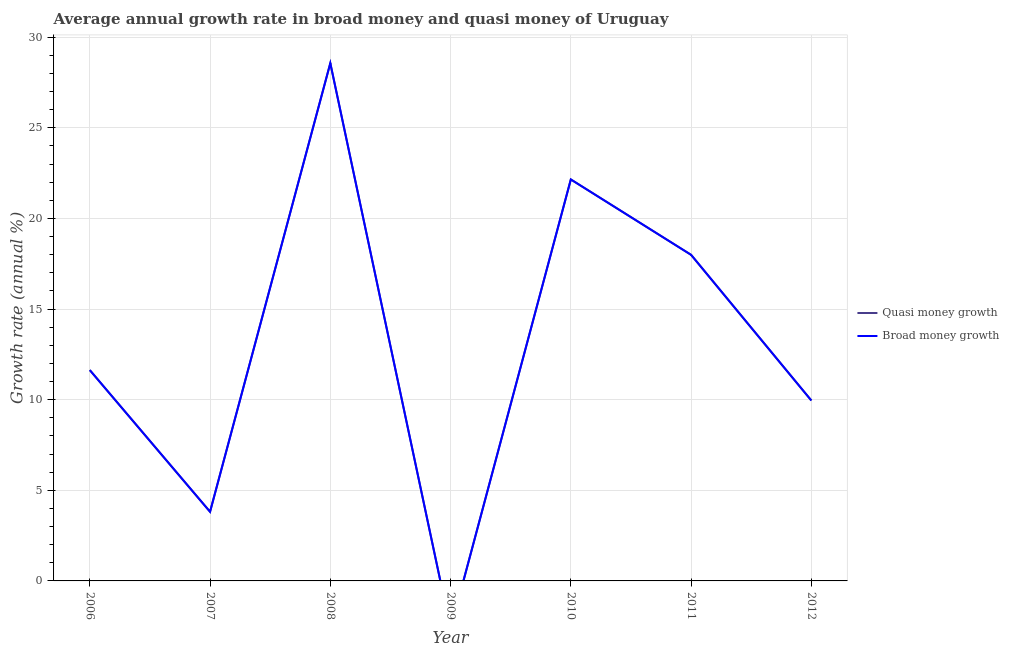Is the number of lines equal to the number of legend labels?
Ensure brevity in your answer.  No. What is the annual growth rate in quasi money in 2007?
Your answer should be compact. 3.82. Across all years, what is the maximum annual growth rate in broad money?
Your answer should be compact. 28.57. What is the total annual growth rate in broad money in the graph?
Provide a short and direct response. 94.11. What is the difference between the annual growth rate in quasi money in 2007 and that in 2008?
Make the answer very short. -24.75. What is the difference between the annual growth rate in broad money in 2007 and the annual growth rate in quasi money in 2008?
Offer a very short reply. -24.75. What is the average annual growth rate in quasi money per year?
Offer a terse response. 13.44. In the year 2012, what is the difference between the annual growth rate in broad money and annual growth rate in quasi money?
Your answer should be very brief. 0. In how many years, is the annual growth rate in quasi money greater than 3 %?
Keep it short and to the point. 6. What is the ratio of the annual growth rate in broad money in 2006 to that in 2010?
Ensure brevity in your answer.  0.53. What is the difference between the highest and the second highest annual growth rate in quasi money?
Your answer should be compact. 6.42. What is the difference between the highest and the lowest annual growth rate in quasi money?
Your answer should be compact. 28.57. In how many years, is the annual growth rate in quasi money greater than the average annual growth rate in quasi money taken over all years?
Provide a succinct answer. 3. Is the annual growth rate in quasi money strictly greater than the annual growth rate in broad money over the years?
Provide a short and direct response. No. How many lines are there?
Offer a very short reply. 2. What is the difference between two consecutive major ticks on the Y-axis?
Offer a very short reply. 5. Does the graph contain any zero values?
Ensure brevity in your answer.  Yes. How many legend labels are there?
Provide a succinct answer. 2. How are the legend labels stacked?
Your response must be concise. Vertical. What is the title of the graph?
Provide a succinct answer. Average annual growth rate in broad money and quasi money of Uruguay. What is the label or title of the Y-axis?
Your answer should be compact. Growth rate (annual %). What is the Growth rate (annual %) of Quasi money growth in 2006?
Ensure brevity in your answer.  11.63. What is the Growth rate (annual %) of Broad money growth in 2006?
Your response must be concise. 11.63. What is the Growth rate (annual %) in Quasi money growth in 2007?
Provide a succinct answer. 3.82. What is the Growth rate (annual %) of Broad money growth in 2007?
Offer a terse response. 3.82. What is the Growth rate (annual %) in Quasi money growth in 2008?
Keep it short and to the point. 28.57. What is the Growth rate (annual %) in Broad money growth in 2008?
Give a very brief answer. 28.57. What is the Growth rate (annual %) in Quasi money growth in 2009?
Ensure brevity in your answer.  0. What is the Growth rate (annual %) in Broad money growth in 2009?
Provide a succinct answer. 0. What is the Growth rate (annual %) in Quasi money growth in 2010?
Provide a short and direct response. 22.15. What is the Growth rate (annual %) of Broad money growth in 2010?
Provide a short and direct response. 22.15. What is the Growth rate (annual %) of Quasi money growth in 2011?
Offer a terse response. 17.99. What is the Growth rate (annual %) in Broad money growth in 2011?
Offer a terse response. 17.99. What is the Growth rate (annual %) of Quasi money growth in 2012?
Keep it short and to the point. 9.95. What is the Growth rate (annual %) of Broad money growth in 2012?
Give a very brief answer. 9.95. Across all years, what is the maximum Growth rate (annual %) of Quasi money growth?
Provide a succinct answer. 28.57. Across all years, what is the maximum Growth rate (annual %) in Broad money growth?
Give a very brief answer. 28.57. Across all years, what is the minimum Growth rate (annual %) in Quasi money growth?
Your answer should be very brief. 0. Across all years, what is the minimum Growth rate (annual %) in Broad money growth?
Keep it short and to the point. 0. What is the total Growth rate (annual %) in Quasi money growth in the graph?
Your answer should be very brief. 94.11. What is the total Growth rate (annual %) in Broad money growth in the graph?
Provide a short and direct response. 94.11. What is the difference between the Growth rate (annual %) in Quasi money growth in 2006 and that in 2007?
Offer a very short reply. 7.82. What is the difference between the Growth rate (annual %) in Broad money growth in 2006 and that in 2007?
Offer a very short reply. 7.82. What is the difference between the Growth rate (annual %) of Quasi money growth in 2006 and that in 2008?
Your response must be concise. -16.93. What is the difference between the Growth rate (annual %) of Broad money growth in 2006 and that in 2008?
Keep it short and to the point. -16.93. What is the difference between the Growth rate (annual %) of Quasi money growth in 2006 and that in 2010?
Your answer should be very brief. -10.52. What is the difference between the Growth rate (annual %) of Broad money growth in 2006 and that in 2010?
Provide a short and direct response. -10.52. What is the difference between the Growth rate (annual %) of Quasi money growth in 2006 and that in 2011?
Keep it short and to the point. -6.36. What is the difference between the Growth rate (annual %) of Broad money growth in 2006 and that in 2011?
Your answer should be very brief. -6.36. What is the difference between the Growth rate (annual %) of Quasi money growth in 2006 and that in 2012?
Make the answer very short. 1.68. What is the difference between the Growth rate (annual %) in Broad money growth in 2006 and that in 2012?
Ensure brevity in your answer.  1.68. What is the difference between the Growth rate (annual %) of Quasi money growth in 2007 and that in 2008?
Offer a terse response. -24.75. What is the difference between the Growth rate (annual %) in Broad money growth in 2007 and that in 2008?
Offer a very short reply. -24.75. What is the difference between the Growth rate (annual %) of Quasi money growth in 2007 and that in 2010?
Your response must be concise. -18.33. What is the difference between the Growth rate (annual %) in Broad money growth in 2007 and that in 2010?
Your answer should be very brief. -18.33. What is the difference between the Growth rate (annual %) in Quasi money growth in 2007 and that in 2011?
Offer a very short reply. -14.18. What is the difference between the Growth rate (annual %) in Broad money growth in 2007 and that in 2011?
Your response must be concise. -14.18. What is the difference between the Growth rate (annual %) in Quasi money growth in 2007 and that in 2012?
Your answer should be very brief. -6.14. What is the difference between the Growth rate (annual %) in Broad money growth in 2007 and that in 2012?
Keep it short and to the point. -6.14. What is the difference between the Growth rate (annual %) of Quasi money growth in 2008 and that in 2010?
Provide a succinct answer. 6.42. What is the difference between the Growth rate (annual %) of Broad money growth in 2008 and that in 2010?
Keep it short and to the point. 6.42. What is the difference between the Growth rate (annual %) of Quasi money growth in 2008 and that in 2011?
Offer a terse response. 10.57. What is the difference between the Growth rate (annual %) of Broad money growth in 2008 and that in 2011?
Your response must be concise. 10.57. What is the difference between the Growth rate (annual %) of Quasi money growth in 2008 and that in 2012?
Keep it short and to the point. 18.61. What is the difference between the Growth rate (annual %) of Broad money growth in 2008 and that in 2012?
Offer a very short reply. 18.61. What is the difference between the Growth rate (annual %) in Quasi money growth in 2010 and that in 2011?
Your answer should be very brief. 4.16. What is the difference between the Growth rate (annual %) of Broad money growth in 2010 and that in 2011?
Your response must be concise. 4.16. What is the difference between the Growth rate (annual %) of Quasi money growth in 2010 and that in 2012?
Your answer should be compact. 12.2. What is the difference between the Growth rate (annual %) in Broad money growth in 2010 and that in 2012?
Keep it short and to the point. 12.2. What is the difference between the Growth rate (annual %) of Quasi money growth in 2011 and that in 2012?
Your answer should be compact. 8.04. What is the difference between the Growth rate (annual %) of Broad money growth in 2011 and that in 2012?
Provide a short and direct response. 8.04. What is the difference between the Growth rate (annual %) in Quasi money growth in 2006 and the Growth rate (annual %) in Broad money growth in 2007?
Provide a short and direct response. 7.82. What is the difference between the Growth rate (annual %) in Quasi money growth in 2006 and the Growth rate (annual %) in Broad money growth in 2008?
Your response must be concise. -16.93. What is the difference between the Growth rate (annual %) of Quasi money growth in 2006 and the Growth rate (annual %) of Broad money growth in 2010?
Keep it short and to the point. -10.52. What is the difference between the Growth rate (annual %) of Quasi money growth in 2006 and the Growth rate (annual %) of Broad money growth in 2011?
Make the answer very short. -6.36. What is the difference between the Growth rate (annual %) in Quasi money growth in 2006 and the Growth rate (annual %) in Broad money growth in 2012?
Keep it short and to the point. 1.68. What is the difference between the Growth rate (annual %) of Quasi money growth in 2007 and the Growth rate (annual %) of Broad money growth in 2008?
Provide a succinct answer. -24.75. What is the difference between the Growth rate (annual %) in Quasi money growth in 2007 and the Growth rate (annual %) in Broad money growth in 2010?
Provide a short and direct response. -18.33. What is the difference between the Growth rate (annual %) of Quasi money growth in 2007 and the Growth rate (annual %) of Broad money growth in 2011?
Your response must be concise. -14.18. What is the difference between the Growth rate (annual %) in Quasi money growth in 2007 and the Growth rate (annual %) in Broad money growth in 2012?
Your answer should be very brief. -6.14. What is the difference between the Growth rate (annual %) in Quasi money growth in 2008 and the Growth rate (annual %) in Broad money growth in 2010?
Make the answer very short. 6.42. What is the difference between the Growth rate (annual %) in Quasi money growth in 2008 and the Growth rate (annual %) in Broad money growth in 2011?
Make the answer very short. 10.57. What is the difference between the Growth rate (annual %) of Quasi money growth in 2008 and the Growth rate (annual %) of Broad money growth in 2012?
Keep it short and to the point. 18.61. What is the difference between the Growth rate (annual %) of Quasi money growth in 2010 and the Growth rate (annual %) of Broad money growth in 2011?
Your answer should be very brief. 4.16. What is the difference between the Growth rate (annual %) of Quasi money growth in 2010 and the Growth rate (annual %) of Broad money growth in 2012?
Make the answer very short. 12.2. What is the difference between the Growth rate (annual %) in Quasi money growth in 2011 and the Growth rate (annual %) in Broad money growth in 2012?
Your answer should be compact. 8.04. What is the average Growth rate (annual %) of Quasi money growth per year?
Provide a short and direct response. 13.44. What is the average Growth rate (annual %) in Broad money growth per year?
Offer a terse response. 13.44. What is the ratio of the Growth rate (annual %) of Quasi money growth in 2006 to that in 2007?
Make the answer very short. 3.05. What is the ratio of the Growth rate (annual %) of Broad money growth in 2006 to that in 2007?
Ensure brevity in your answer.  3.05. What is the ratio of the Growth rate (annual %) in Quasi money growth in 2006 to that in 2008?
Offer a very short reply. 0.41. What is the ratio of the Growth rate (annual %) in Broad money growth in 2006 to that in 2008?
Provide a short and direct response. 0.41. What is the ratio of the Growth rate (annual %) of Quasi money growth in 2006 to that in 2010?
Your answer should be very brief. 0.53. What is the ratio of the Growth rate (annual %) in Broad money growth in 2006 to that in 2010?
Make the answer very short. 0.53. What is the ratio of the Growth rate (annual %) of Quasi money growth in 2006 to that in 2011?
Offer a terse response. 0.65. What is the ratio of the Growth rate (annual %) in Broad money growth in 2006 to that in 2011?
Your answer should be very brief. 0.65. What is the ratio of the Growth rate (annual %) of Quasi money growth in 2006 to that in 2012?
Provide a short and direct response. 1.17. What is the ratio of the Growth rate (annual %) in Broad money growth in 2006 to that in 2012?
Ensure brevity in your answer.  1.17. What is the ratio of the Growth rate (annual %) in Quasi money growth in 2007 to that in 2008?
Offer a very short reply. 0.13. What is the ratio of the Growth rate (annual %) in Broad money growth in 2007 to that in 2008?
Make the answer very short. 0.13. What is the ratio of the Growth rate (annual %) in Quasi money growth in 2007 to that in 2010?
Provide a short and direct response. 0.17. What is the ratio of the Growth rate (annual %) of Broad money growth in 2007 to that in 2010?
Offer a very short reply. 0.17. What is the ratio of the Growth rate (annual %) in Quasi money growth in 2007 to that in 2011?
Offer a very short reply. 0.21. What is the ratio of the Growth rate (annual %) of Broad money growth in 2007 to that in 2011?
Provide a succinct answer. 0.21. What is the ratio of the Growth rate (annual %) in Quasi money growth in 2007 to that in 2012?
Your answer should be very brief. 0.38. What is the ratio of the Growth rate (annual %) in Broad money growth in 2007 to that in 2012?
Your answer should be very brief. 0.38. What is the ratio of the Growth rate (annual %) in Quasi money growth in 2008 to that in 2010?
Provide a succinct answer. 1.29. What is the ratio of the Growth rate (annual %) in Broad money growth in 2008 to that in 2010?
Your answer should be compact. 1.29. What is the ratio of the Growth rate (annual %) in Quasi money growth in 2008 to that in 2011?
Provide a short and direct response. 1.59. What is the ratio of the Growth rate (annual %) in Broad money growth in 2008 to that in 2011?
Offer a very short reply. 1.59. What is the ratio of the Growth rate (annual %) in Quasi money growth in 2008 to that in 2012?
Ensure brevity in your answer.  2.87. What is the ratio of the Growth rate (annual %) of Broad money growth in 2008 to that in 2012?
Keep it short and to the point. 2.87. What is the ratio of the Growth rate (annual %) of Quasi money growth in 2010 to that in 2011?
Offer a very short reply. 1.23. What is the ratio of the Growth rate (annual %) in Broad money growth in 2010 to that in 2011?
Offer a very short reply. 1.23. What is the ratio of the Growth rate (annual %) of Quasi money growth in 2010 to that in 2012?
Provide a short and direct response. 2.23. What is the ratio of the Growth rate (annual %) in Broad money growth in 2010 to that in 2012?
Ensure brevity in your answer.  2.23. What is the ratio of the Growth rate (annual %) of Quasi money growth in 2011 to that in 2012?
Give a very brief answer. 1.81. What is the ratio of the Growth rate (annual %) in Broad money growth in 2011 to that in 2012?
Offer a very short reply. 1.81. What is the difference between the highest and the second highest Growth rate (annual %) in Quasi money growth?
Offer a terse response. 6.42. What is the difference between the highest and the second highest Growth rate (annual %) in Broad money growth?
Make the answer very short. 6.42. What is the difference between the highest and the lowest Growth rate (annual %) in Quasi money growth?
Your answer should be very brief. 28.57. What is the difference between the highest and the lowest Growth rate (annual %) of Broad money growth?
Ensure brevity in your answer.  28.57. 